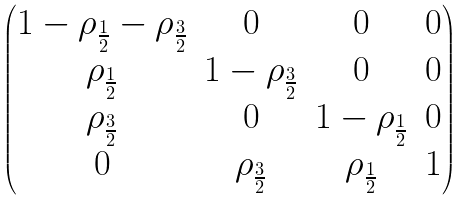Convert formula to latex. <formula><loc_0><loc_0><loc_500><loc_500>\begin{pmatrix} 1 - \rho _ { \frac { 1 } { 2 } } - \rho _ { \frac { 3 } { 2 } } & 0 & 0 & 0 \\ \rho _ { \frac { 1 } { 2 } } & 1 - \rho _ { \frac { 3 } { 2 } } & 0 & 0 \\ \rho _ { \frac { 3 } { 2 } } & 0 & 1 - \rho _ { \frac { 1 } { 2 } } & 0 \\ 0 & \rho _ { \frac { 3 } { 2 } } & \rho _ { \frac { 1 } { 2 } } & 1 \end{pmatrix}</formula> 